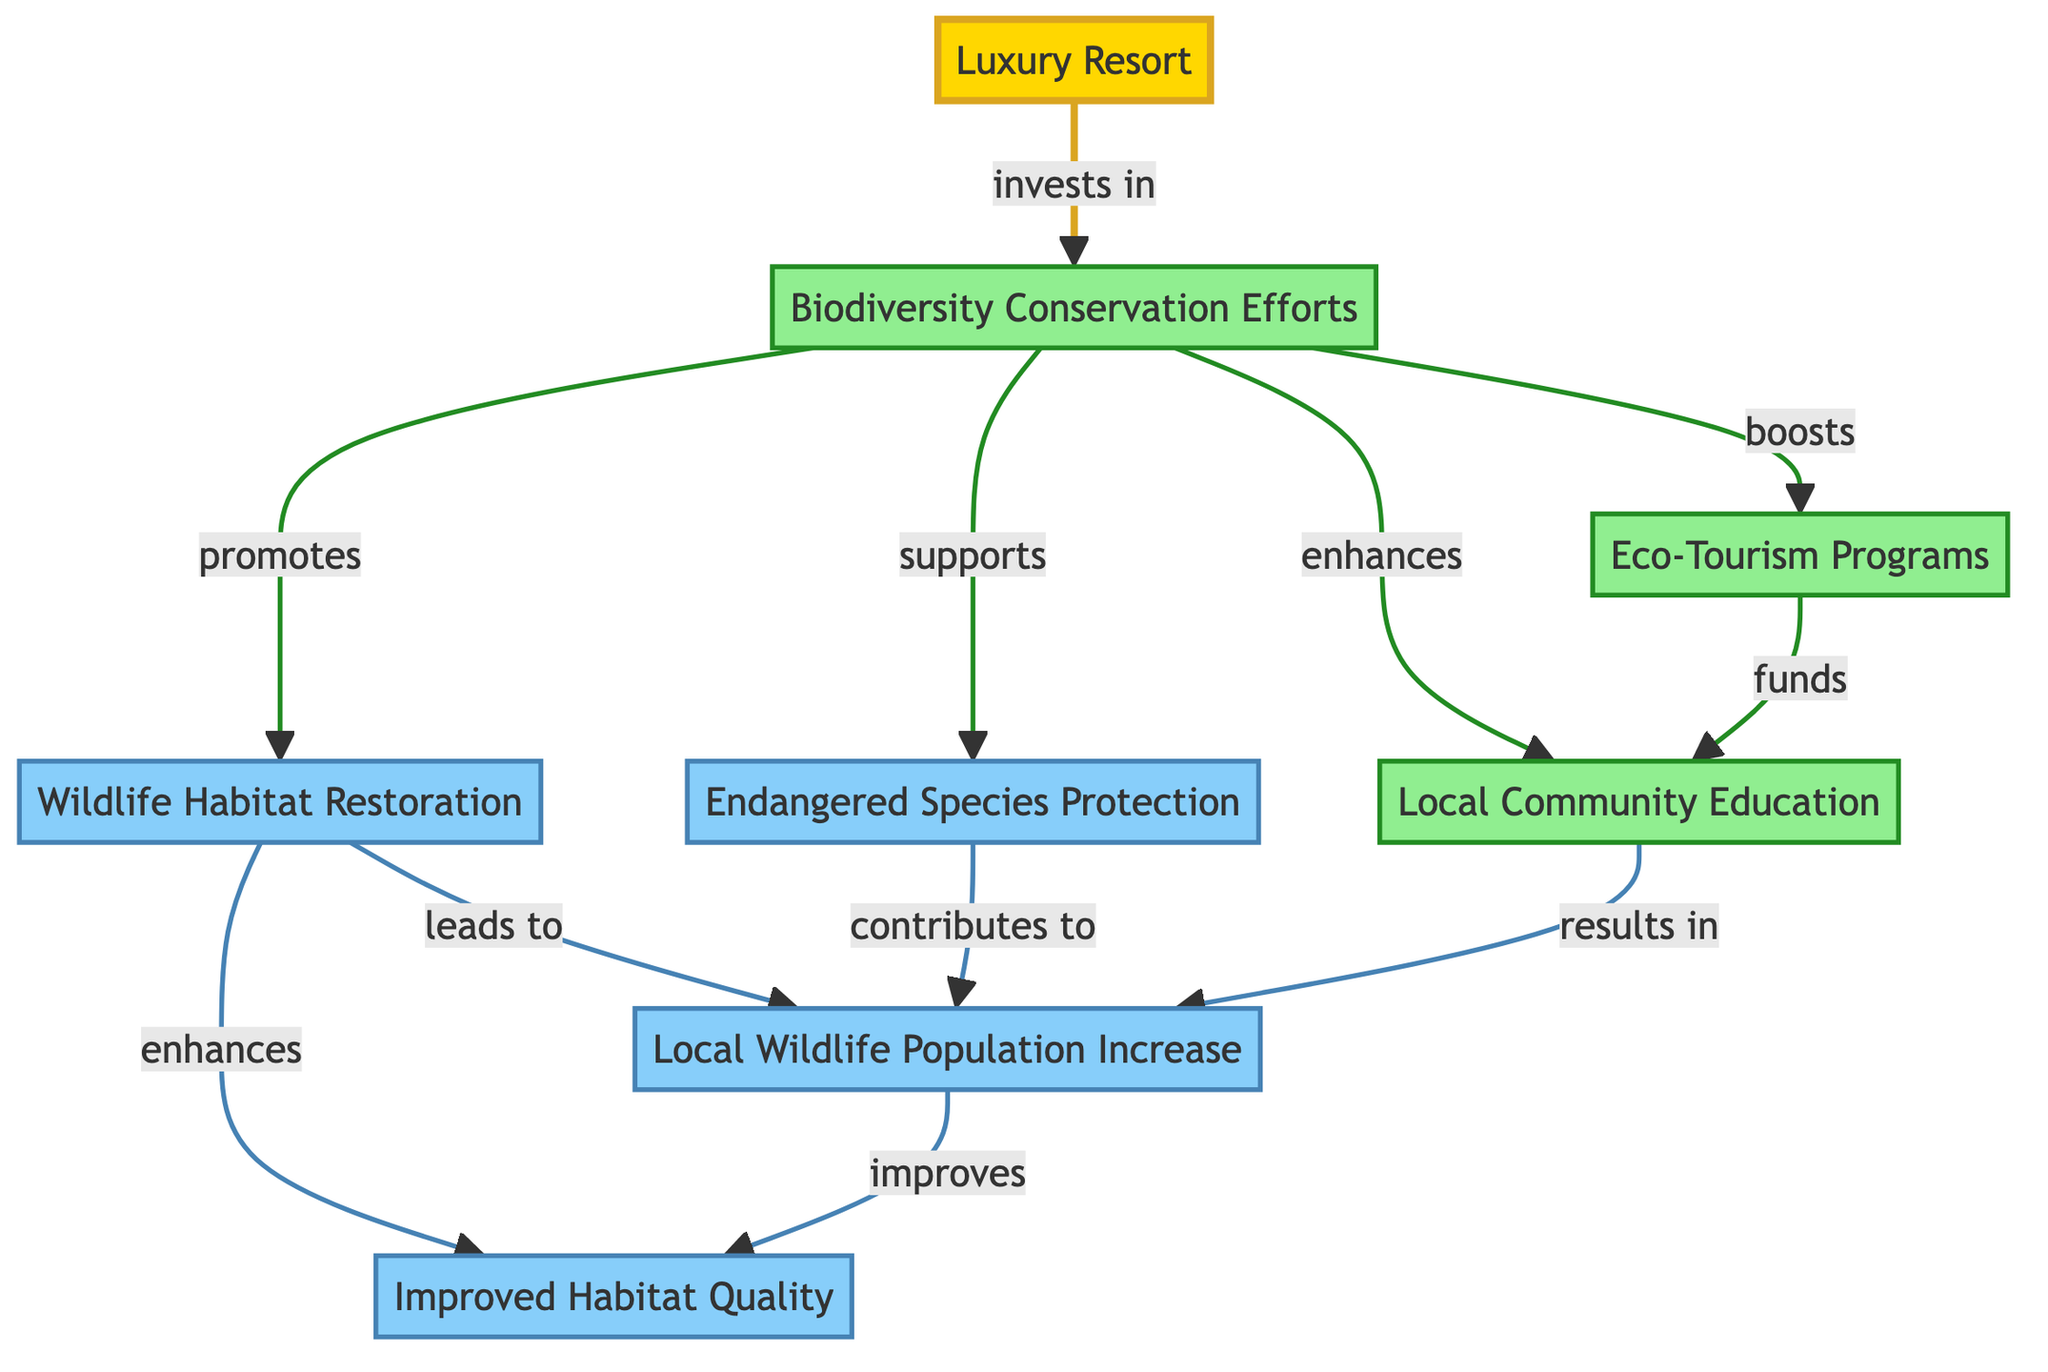What's the main investment of the luxury resort? The diagram indicates that the luxury resort invests in biodiversity conservation efforts. This can be seen in the arrow directly connecting the resort to biodiversity conservation.
Answer: biodiversity conservation efforts How many types of biodiversity conservation efforts are listed? The diagram shows four distinct types of biodiversity conservation efforts linked to the main conservation node: wildlife habitat restoration, endangered species protection, eco-tourism programs, and local community education. Counting these links provides the total number of types.
Answer: 4 What results from wildlife habitat restoration? According to the diagram, wildlife habitat restoration leads to an increase in local wildlife population, as indicated by the arrow showing this direct relationship.
Answer: wildlife population increase How does local community education influence wildlife? The diagram shows that local community education results in an increase in local wildlife population, indicating that educating the community has a positive effect on wildlife numbers.
Answer: wildlife population increase Which conservation effort funds local community education? The diagram indicates that eco-tourism programs fund local community education, as this relationship is shown by the arrow connecting eco-tourism to local education.
Answer: eco-tourism programs What effect does improved habitat quality have on wildlife? The diagram suggests that an improvement in habitat quality is linked to the increase in local wildlife population. This indicates that higher habitat quality provides better conditions for wildlife to thrive.
Answer: wildlife population increase Which biodiversity conservation effort enhances habitat quality? The diagram indicates that wildlife habitat restoration enhances habitat quality, as shown by the direct link from wildlife habitat restoration to improved habitat quality.
Answer: wildlife habitat restoration What type of programs are boosted by biodiversity conservation efforts? The diagram reveals that eco-tourism programs are boosted by biodiversity conservation efforts, highlighting their interdependent relationship as one benefits from the other.
Answer: eco-tourism programs How is local wildlife population affected by endangered species protection? The diagram shows that endangered species protection contributes to the local wildlife population, which indicates that protecting these species has a positive impact on overall wildlife numbers.
Answer: wildlife population increase 